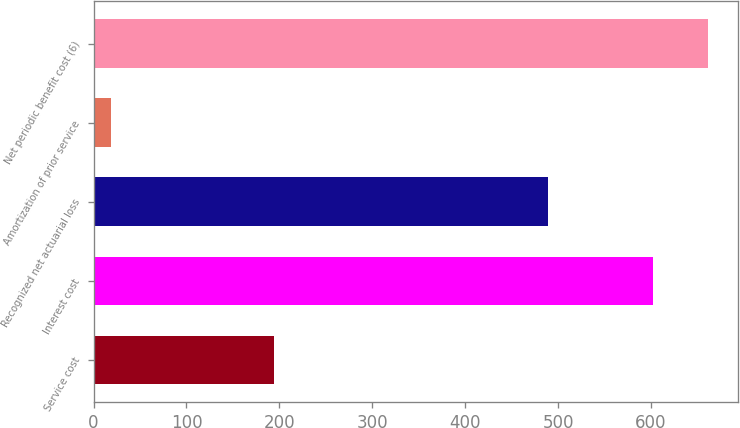Convert chart. <chart><loc_0><loc_0><loc_500><loc_500><bar_chart><fcel>Service cost<fcel>Interest cost<fcel>Recognized net actuarial loss<fcel>Amortization of prior service<fcel>Net periodic benefit cost (6)<nl><fcel>194<fcel>602<fcel>489<fcel>19<fcel>660.9<nl></chart> 